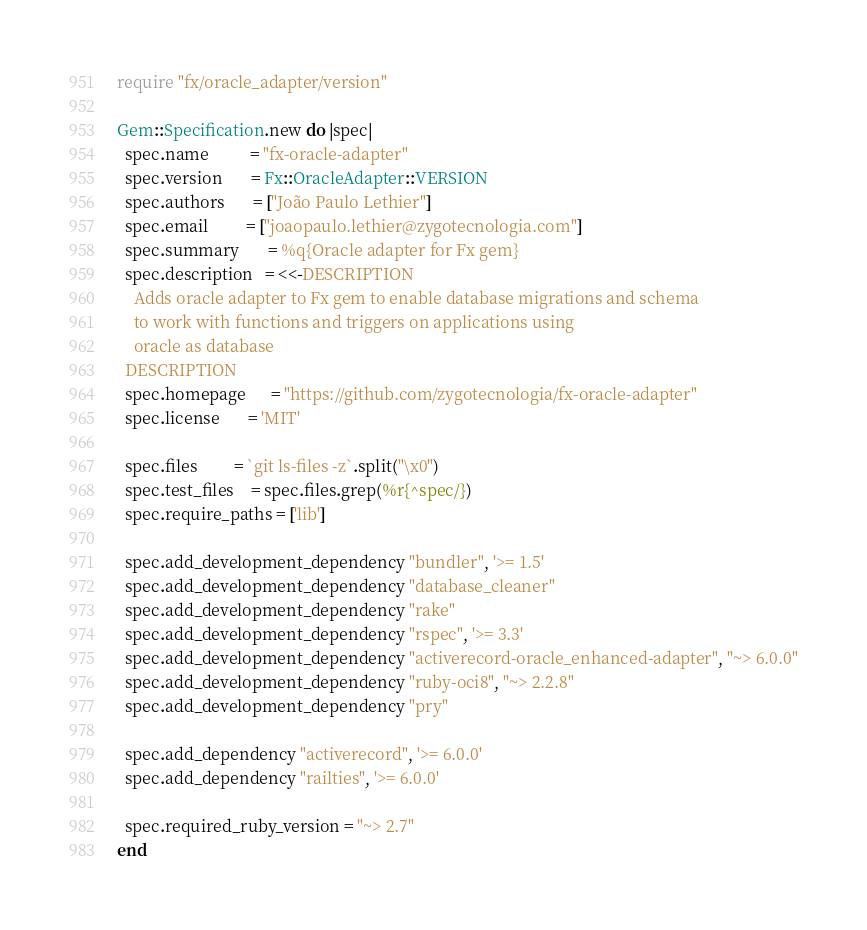Convert code to text. <code><loc_0><loc_0><loc_500><loc_500><_Ruby_>require "fx/oracle_adapter/version"

Gem::Specification.new do |spec|
  spec.name          = "fx-oracle-adapter"
  spec.version       = Fx::OracleAdapter::VERSION
  spec.authors       = ["João Paulo Lethier"]
  spec.email         = ["joaopaulo.lethier@zygotecnologia.com"]
  spec.summary       = %q{Oracle adapter for Fx gem}
  spec.description   = <<-DESCRIPTION
    Adds oracle adapter to Fx gem to enable database migrations and schema
    to work with functions and triggers on applications using
    oracle as database
  DESCRIPTION
  spec.homepage      = "https://github.com/zygotecnologia/fx-oracle-adapter"
  spec.license       = 'MIT'

  spec.files         = `git ls-files -z`.split("\x0")
  spec.test_files    = spec.files.grep(%r{^spec/})
  spec.require_paths = ['lib']

  spec.add_development_dependency "bundler", '>= 1.5'
  spec.add_development_dependency "database_cleaner"
  spec.add_development_dependency "rake"
  spec.add_development_dependency "rspec", '>= 3.3'
  spec.add_development_dependency "activerecord-oracle_enhanced-adapter", "~> 6.0.0"
  spec.add_development_dependency "ruby-oci8", "~> 2.2.8"
  spec.add_development_dependency "pry"

  spec.add_dependency "activerecord", '>= 6.0.0'
  spec.add_dependency "railties", '>= 6.0.0'

  spec.required_ruby_version = "~> 2.7"
end
</code> 